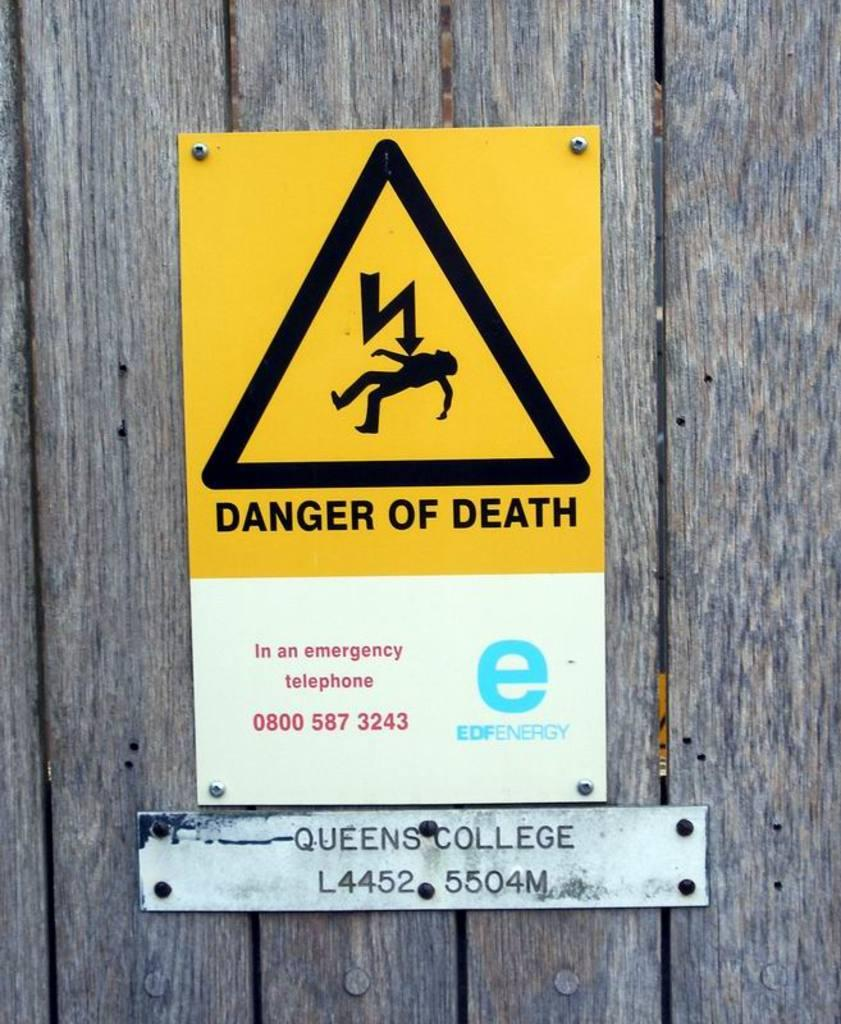<image>
Create a compact narrative representing the image presented. A yellow and black sign that says danger of death on it. 